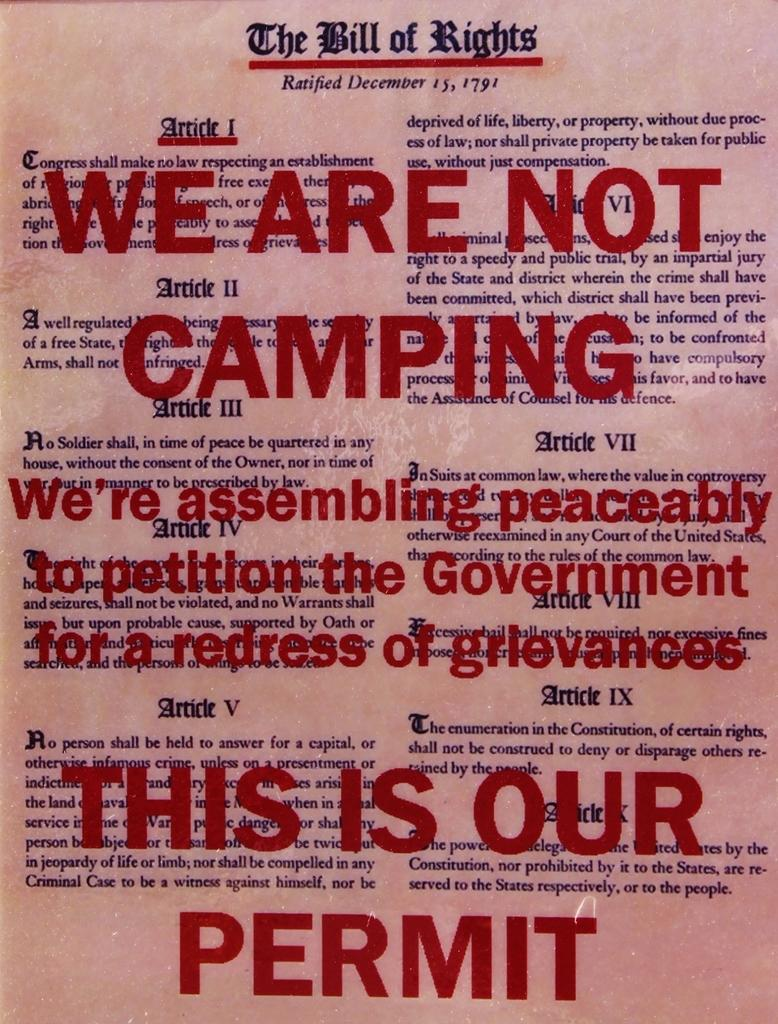<image>
Present a compact description of the photo's key features. a copy of the bill of rights that has red text in bold that reads we are not camping this is our permit. 